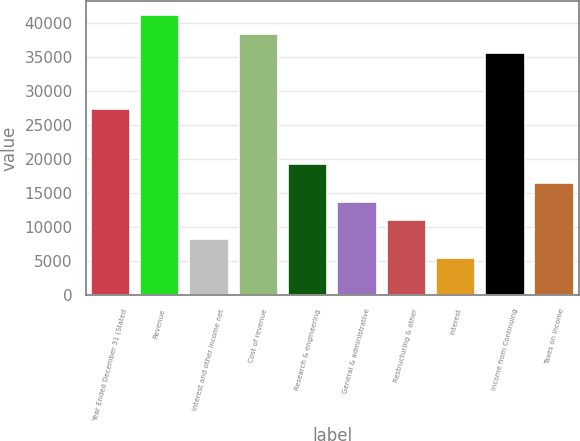<chart> <loc_0><loc_0><loc_500><loc_500><bar_chart><fcel>Year Ended December 31 (Stated<fcel>Revenue<fcel>Interest and other income net<fcel>Cost of revenue<fcel>Research & engineering<fcel>General & administrative<fcel>Restructuring & other<fcel>Interest<fcel>Income from Continuing<fcel>Taxes on income<nl><fcel>27447<fcel>41170<fcel>8234.8<fcel>38425.4<fcel>19213.2<fcel>13724<fcel>10979.4<fcel>5490.2<fcel>35680.8<fcel>16468.6<nl></chart> 